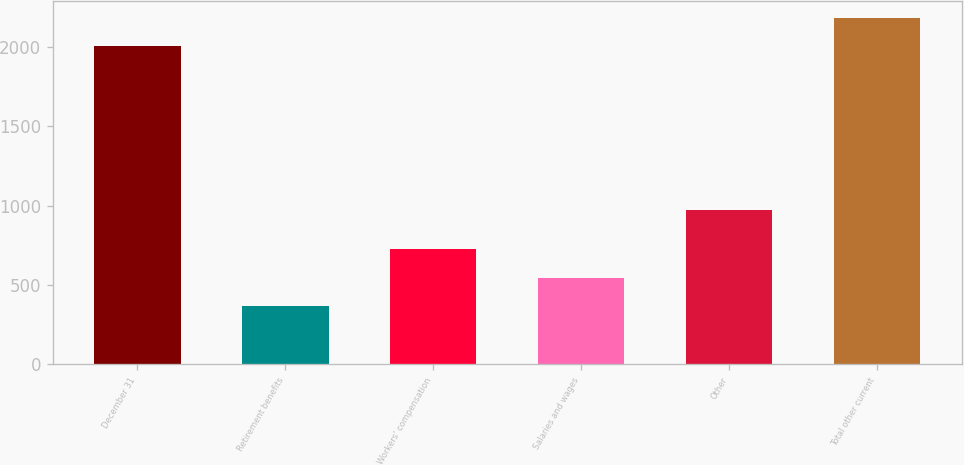Convert chart to OTSL. <chart><loc_0><loc_0><loc_500><loc_500><bar_chart><fcel>December 31<fcel>Retirement benefits<fcel>Workers' compensation<fcel>Salaries and wages<fcel>Other<fcel>Total other current<nl><fcel>2005<fcel>369<fcel>723.8<fcel>546.4<fcel>975<fcel>2182.4<nl></chart> 